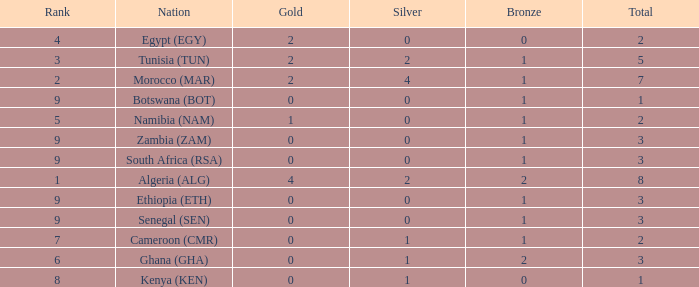What is the total number of Silver with a Total that is smaller than 1? 0.0. 